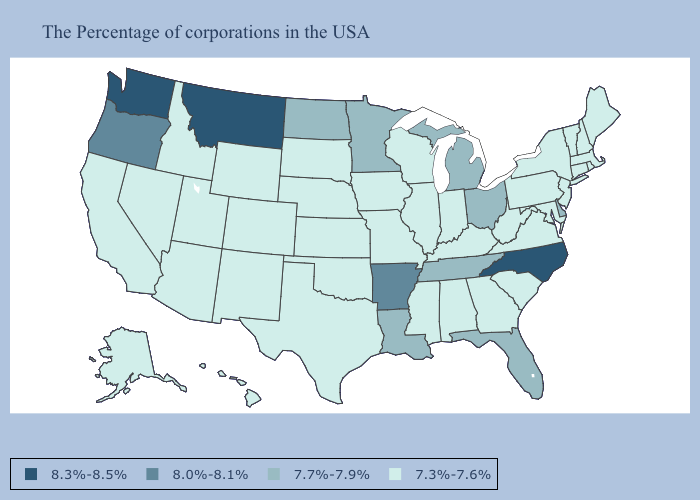Among the states that border Utah , which have the highest value?
Concise answer only. Wyoming, Colorado, New Mexico, Arizona, Idaho, Nevada. Does Missouri have a higher value than Mississippi?
Answer briefly. No. What is the value of Alabama?
Write a very short answer. 7.3%-7.6%. Name the states that have a value in the range 7.3%-7.6%?
Quick response, please. Maine, Massachusetts, Rhode Island, New Hampshire, Vermont, Connecticut, New York, New Jersey, Maryland, Pennsylvania, Virginia, South Carolina, West Virginia, Georgia, Kentucky, Indiana, Alabama, Wisconsin, Illinois, Mississippi, Missouri, Iowa, Kansas, Nebraska, Oklahoma, Texas, South Dakota, Wyoming, Colorado, New Mexico, Utah, Arizona, Idaho, Nevada, California, Alaska, Hawaii. Among the states that border South Dakota , does North Dakota have the lowest value?
Be succinct. No. What is the lowest value in the USA?
Give a very brief answer. 7.3%-7.6%. Does Louisiana have a lower value than Nebraska?
Short answer required. No. Does Washington have a lower value than Wyoming?
Short answer required. No. Is the legend a continuous bar?
Answer briefly. No. What is the lowest value in states that border Colorado?
Keep it brief. 7.3%-7.6%. Name the states that have a value in the range 8.3%-8.5%?
Keep it brief. North Carolina, Montana, Washington. Does the map have missing data?
Give a very brief answer. No. Which states hav the highest value in the West?
Quick response, please. Montana, Washington. Name the states that have a value in the range 8.3%-8.5%?
Be succinct. North Carolina, Montana, Washington. Among the states that border South Dakota , does Nebraska have the lowest value?
Keep it brief. Yes. 